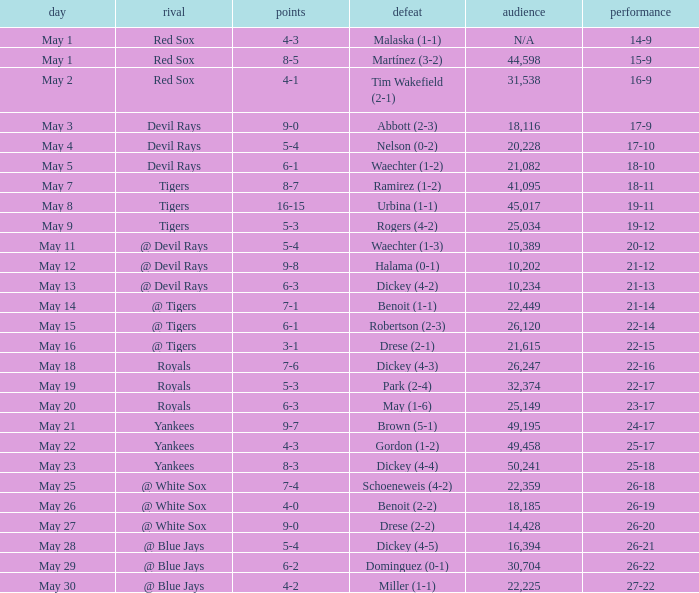What was the result of the contest where drese (2-2) suffered a loss? 9-0. 